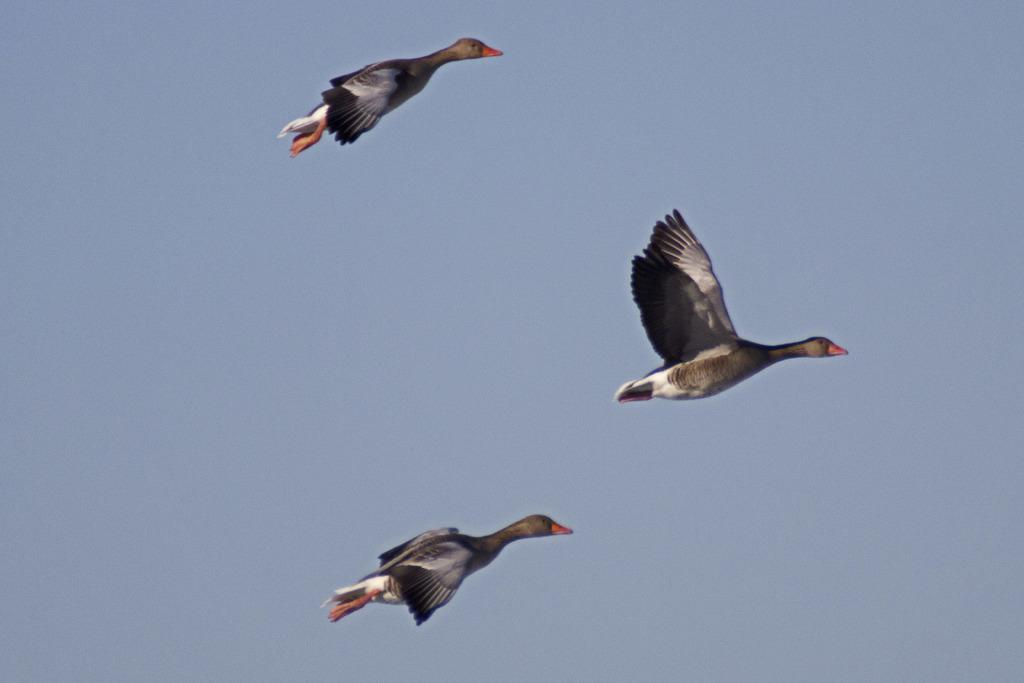What type of animals can be seen in the image? Birds can be seen in the image. What are the birds doing in the image? The birds are flying in the sky. What type of books can be found in the library depicted in the image? There is no library present in the image; it features birds flying in the sky. 